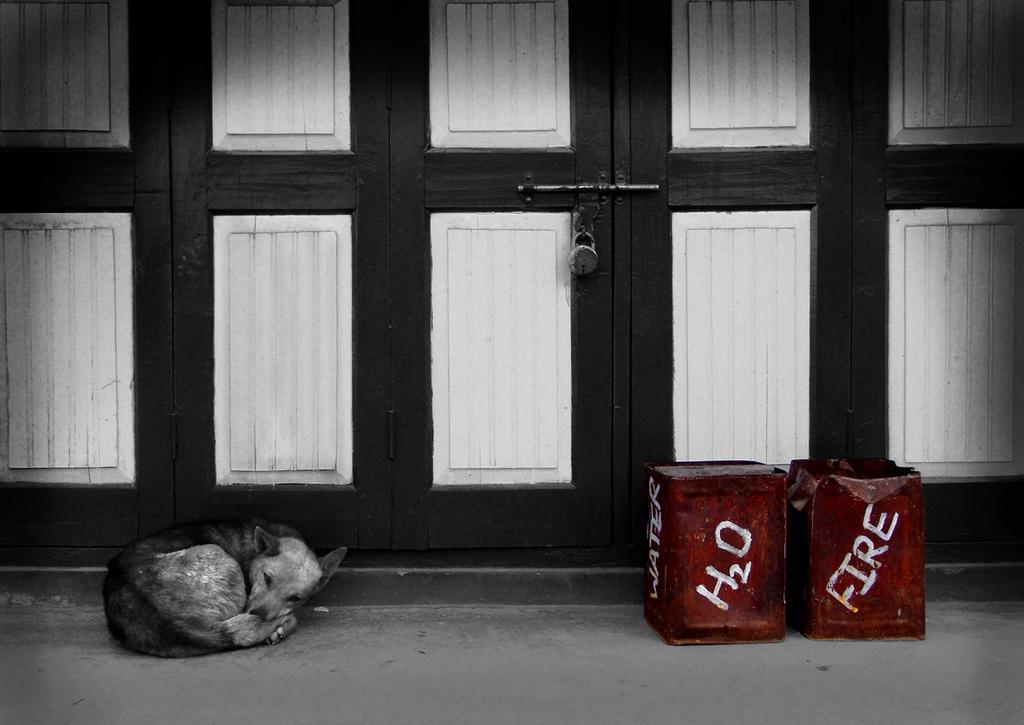In one or two sentences, can you explain what this image depicts? It looks like a black and white picture, we can see a dog is laying on the walkway and behind the dog there are doors with a lock. On the right side of the dog there are two iron containers. 